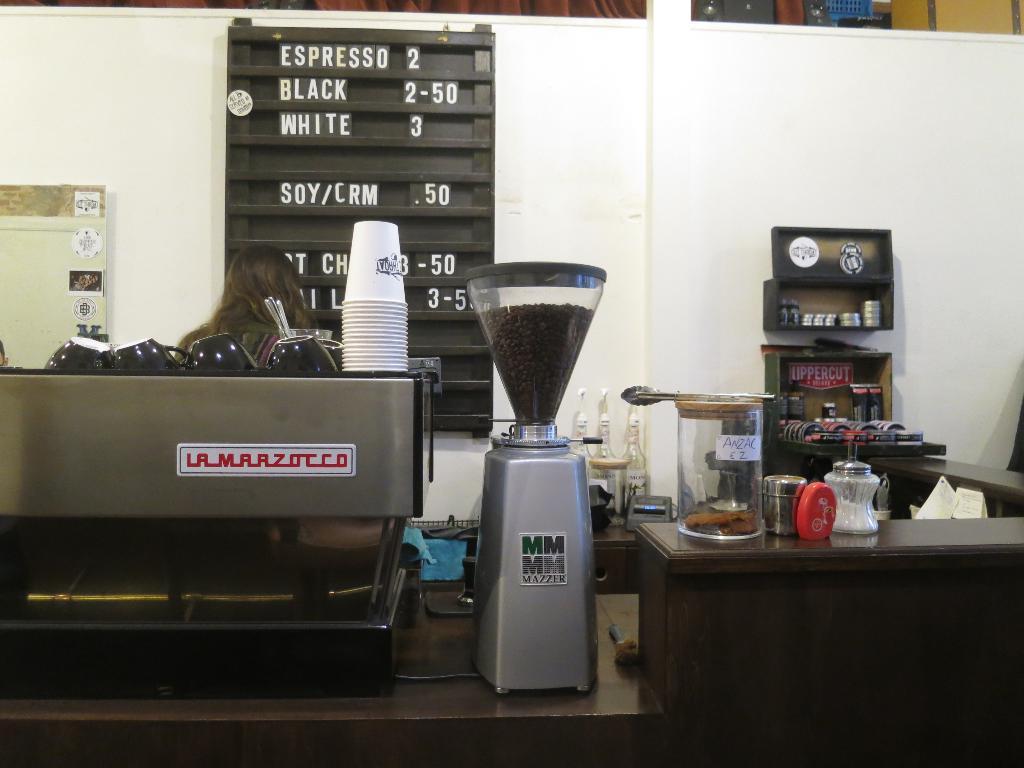What is the additional cost for soy or cream?
Provide a short and direct response. .50. 